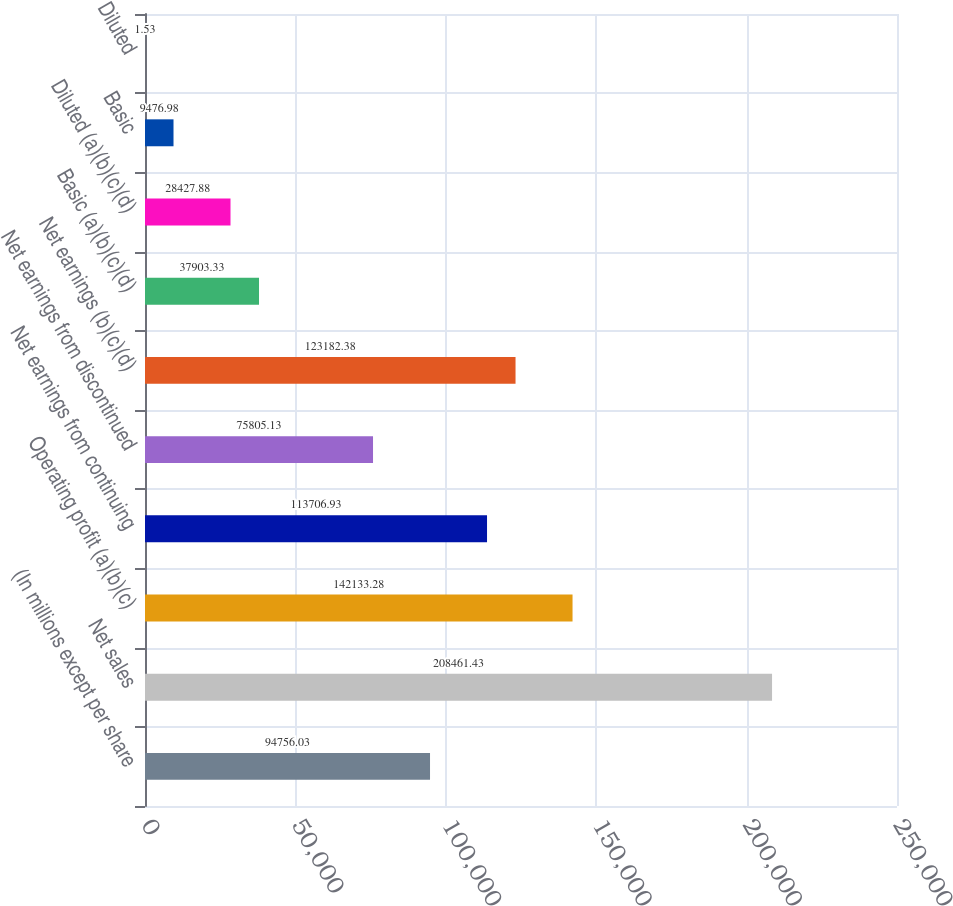Convert chart. <chart><loc_0><loc_0><loc_500><loc_500><bar_chart><fcel>(In millions except per share<fcel>Net sales<fcel>Operating profit (a)(b)(c)<fcel>Net earnings from continuing<fcel>Net earnings from discontinued<fcel>Net earnings (b)(c)(d)<fcel>Basic (a)(b)(c)(d)<fcel>Diluted (a)(b)(c)(d)<fcel>Basic<fcel>Diluted<nl><fcel>94756<fcel>208461<fcel>142133<fcel>113707<fcel>75805.1<fcel>123182<fcel>37903.3<fcel>28427.9<fcel>9476.98<fcel>1.53<nl></chart> 